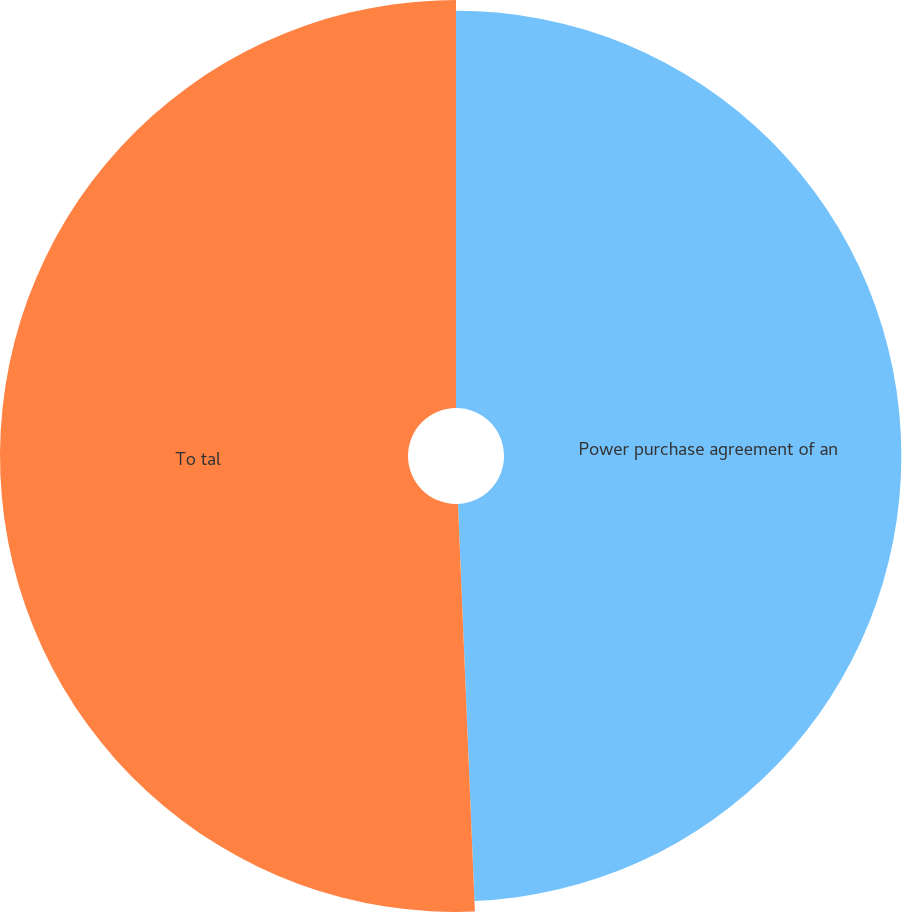Convert chart. <chart><loc_0><loc_0><loc_500><loc_500><pie_chart><fcel>Power purchase agreement of an<fcel>To tal<nl><fcel>49.34%<fcel>50.66%<nl></chart> 